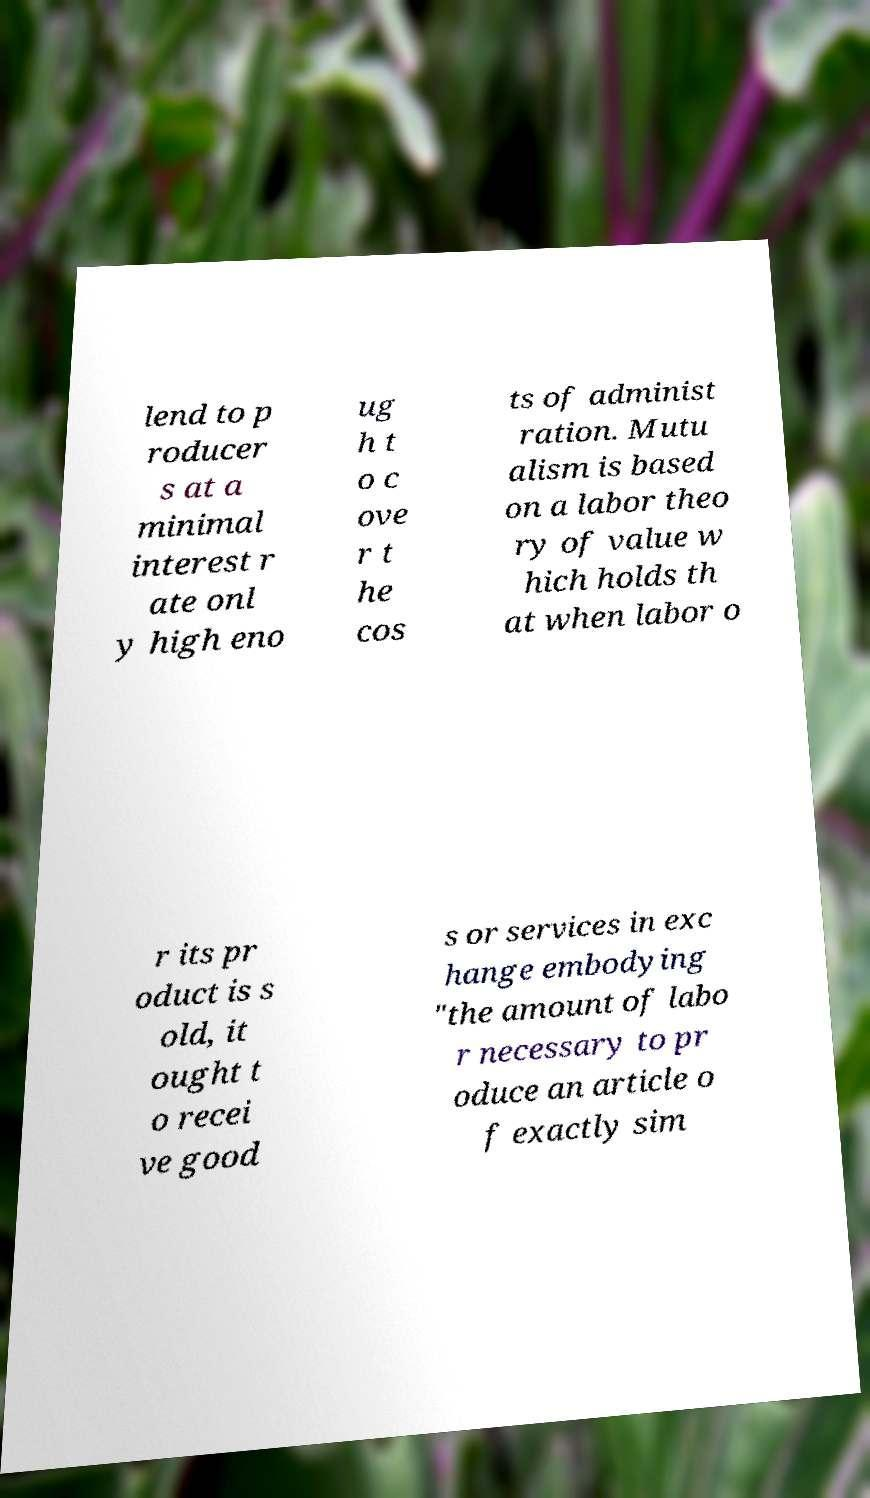Can you accurately transcribe the text from the provided image for me? lend to p roducer s at a minimal interest r ate onl y high eno ug h t o c ove r t he cos ts of administ ration. Mutu alism is based on a labor theo ry of value w hich holds th at when labor o r its pr oduct is s old, it ought t o recei ve good s or services in exc hange embodying "the amount of labo r necessary to pr oduce an article o f exactly sim 